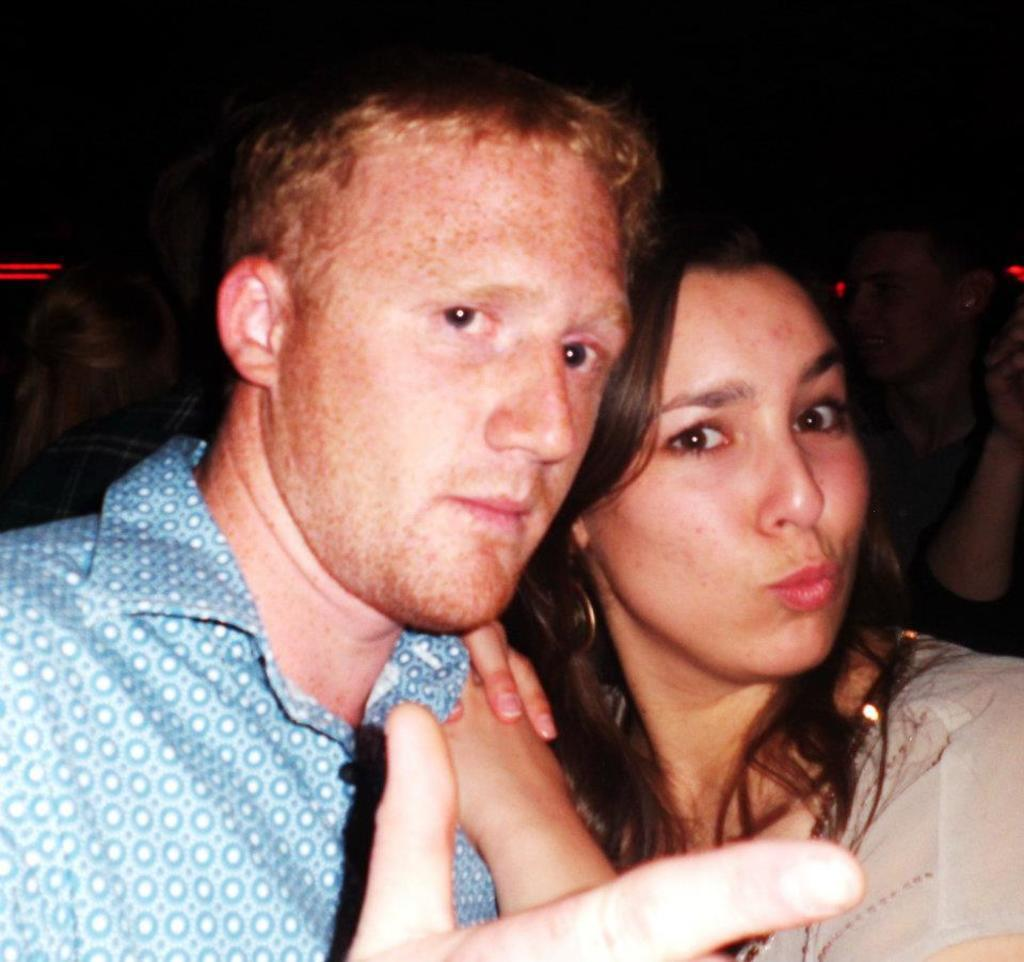What is the man in the image wearing? The man in the image is wearing a blue shirt. What is the woman in the image wearing? The woman in the image is wearing a cream dress. Can you describe the group of people in the background of the image? Unfortunately, the provided facts do not give any details about the group of people in the background. What is the color of the background in the image? The background of the image is black. What type of needle is the man using to sew the woman's dress in the image? There is no needle present in the image, nor is there any indication that the man is sewing the woman's dress. 